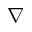<formula> <loc_0><loc_0><loc_500><loc_500>\nabla</formula> 